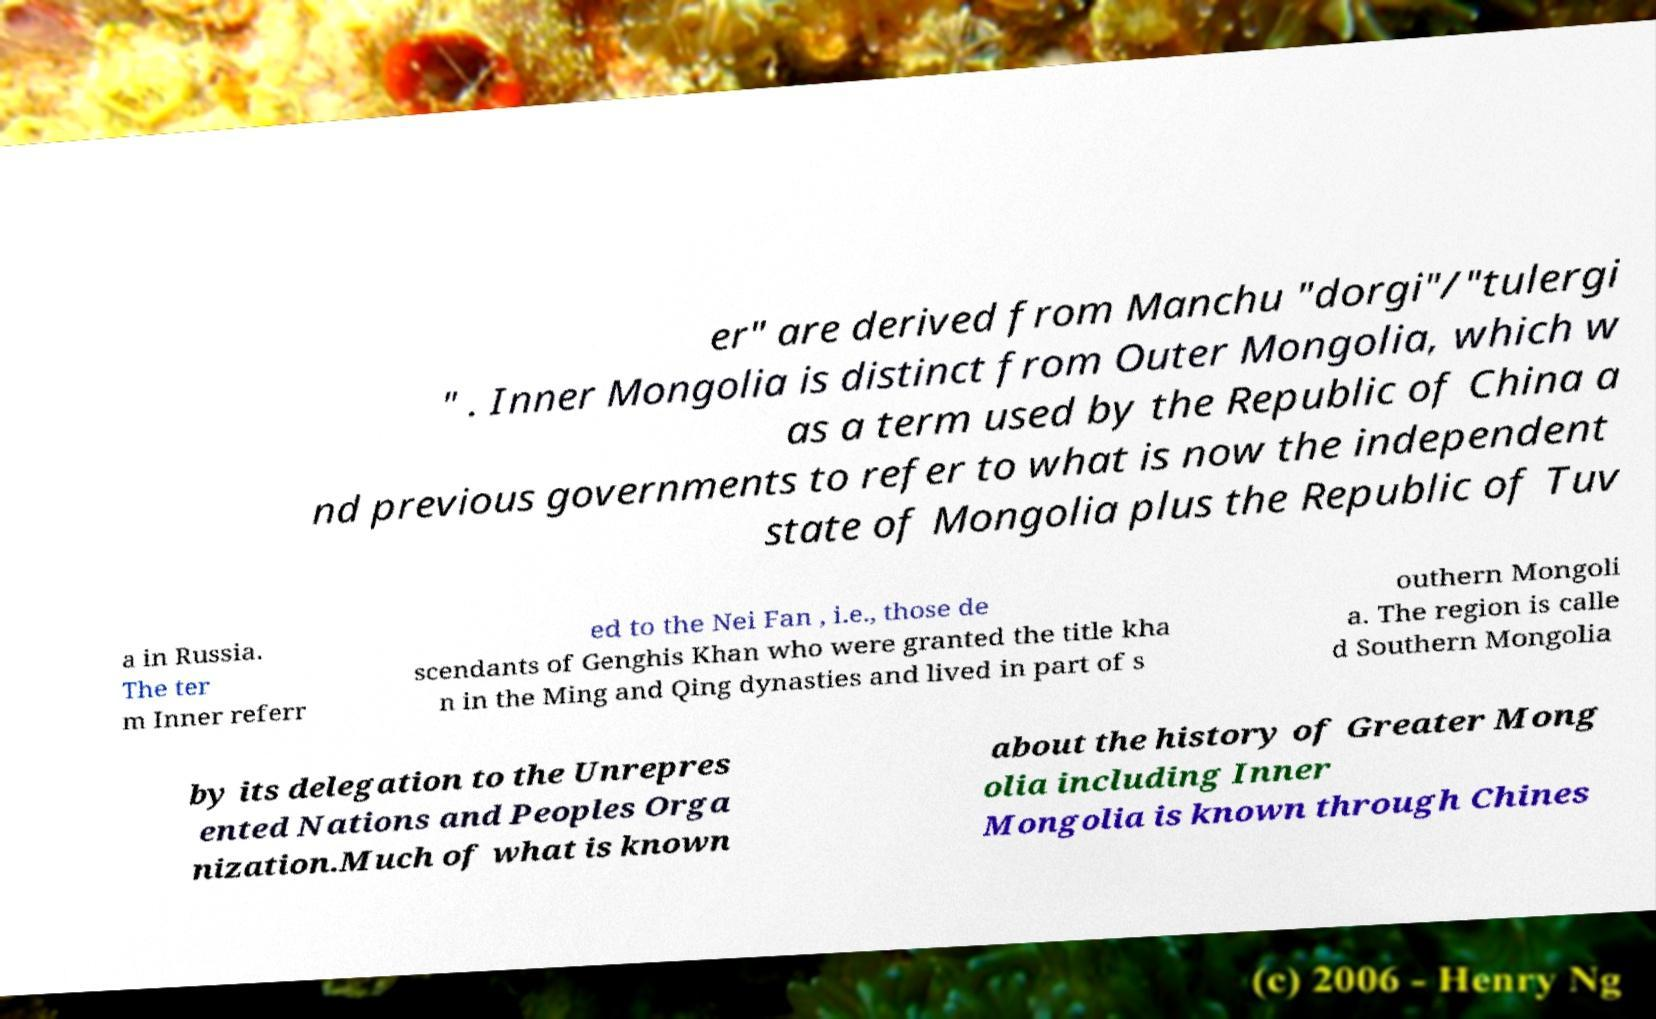Can you read and provide the text displayed in the image?This photo seems to have some interesting text. Can you extract and type it out for me? er" are derived from Manchu "dorgi"/"tulergi " . Inner Mongolia is distinct from Outer Mongolia, which w as a term used by the Republic of China a nd previous governments to refer to what is now the independent state of Mongolia plus the Republic of Tuv a in Russia. The ter m Inner referr ed to the Nei Fan , i.e., those de scendants of Genghis Khan who were granted the title kha n in the Ming and Qing dynasties and lived in part of s outhern Mongoli a. The region is calle d Southern Mongolia by its delegation to the Unrepres ented Nations and Peoples Orga nization.Much of what is known about the history of Greater Mong olia including Inner Mongolia is known through Chines 